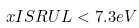Convert formula to latex. <formula><loc_0><loc_0><loc_500><loc_500>\ x I S R U L < 7 . 3 e V</formula> 